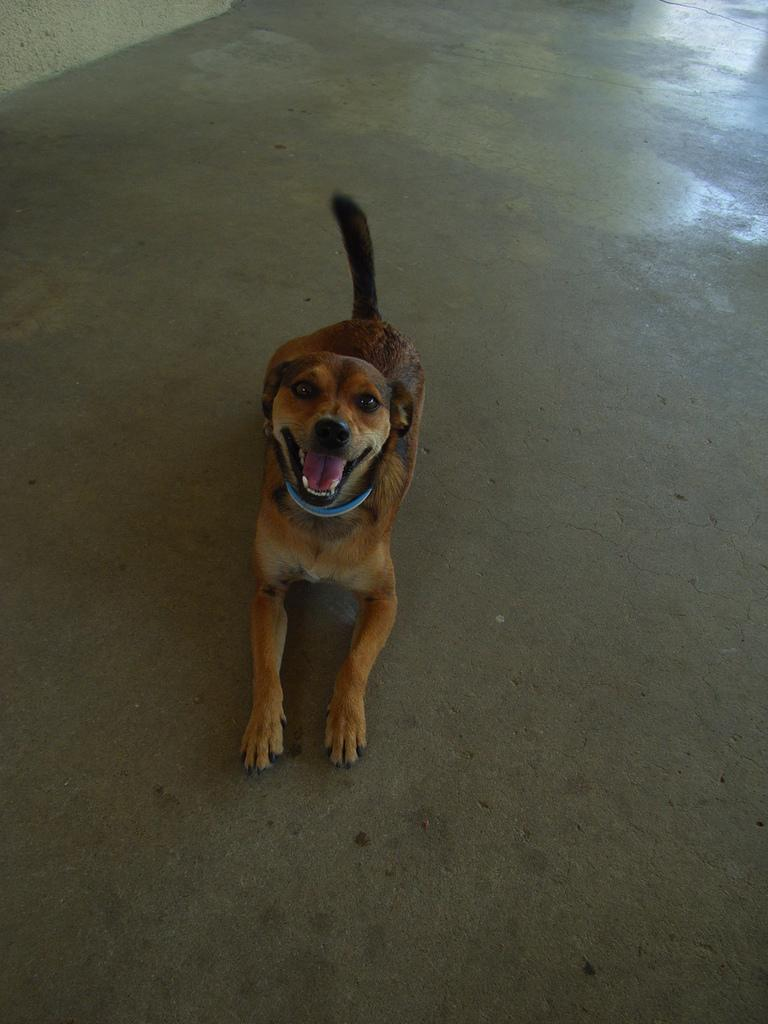What type of animal is present in the image? There is a brown color dog in the image. What color is the roof of the doghouse in the image? There is no doghouse or roof present in the image; it only features a brown color dog. 